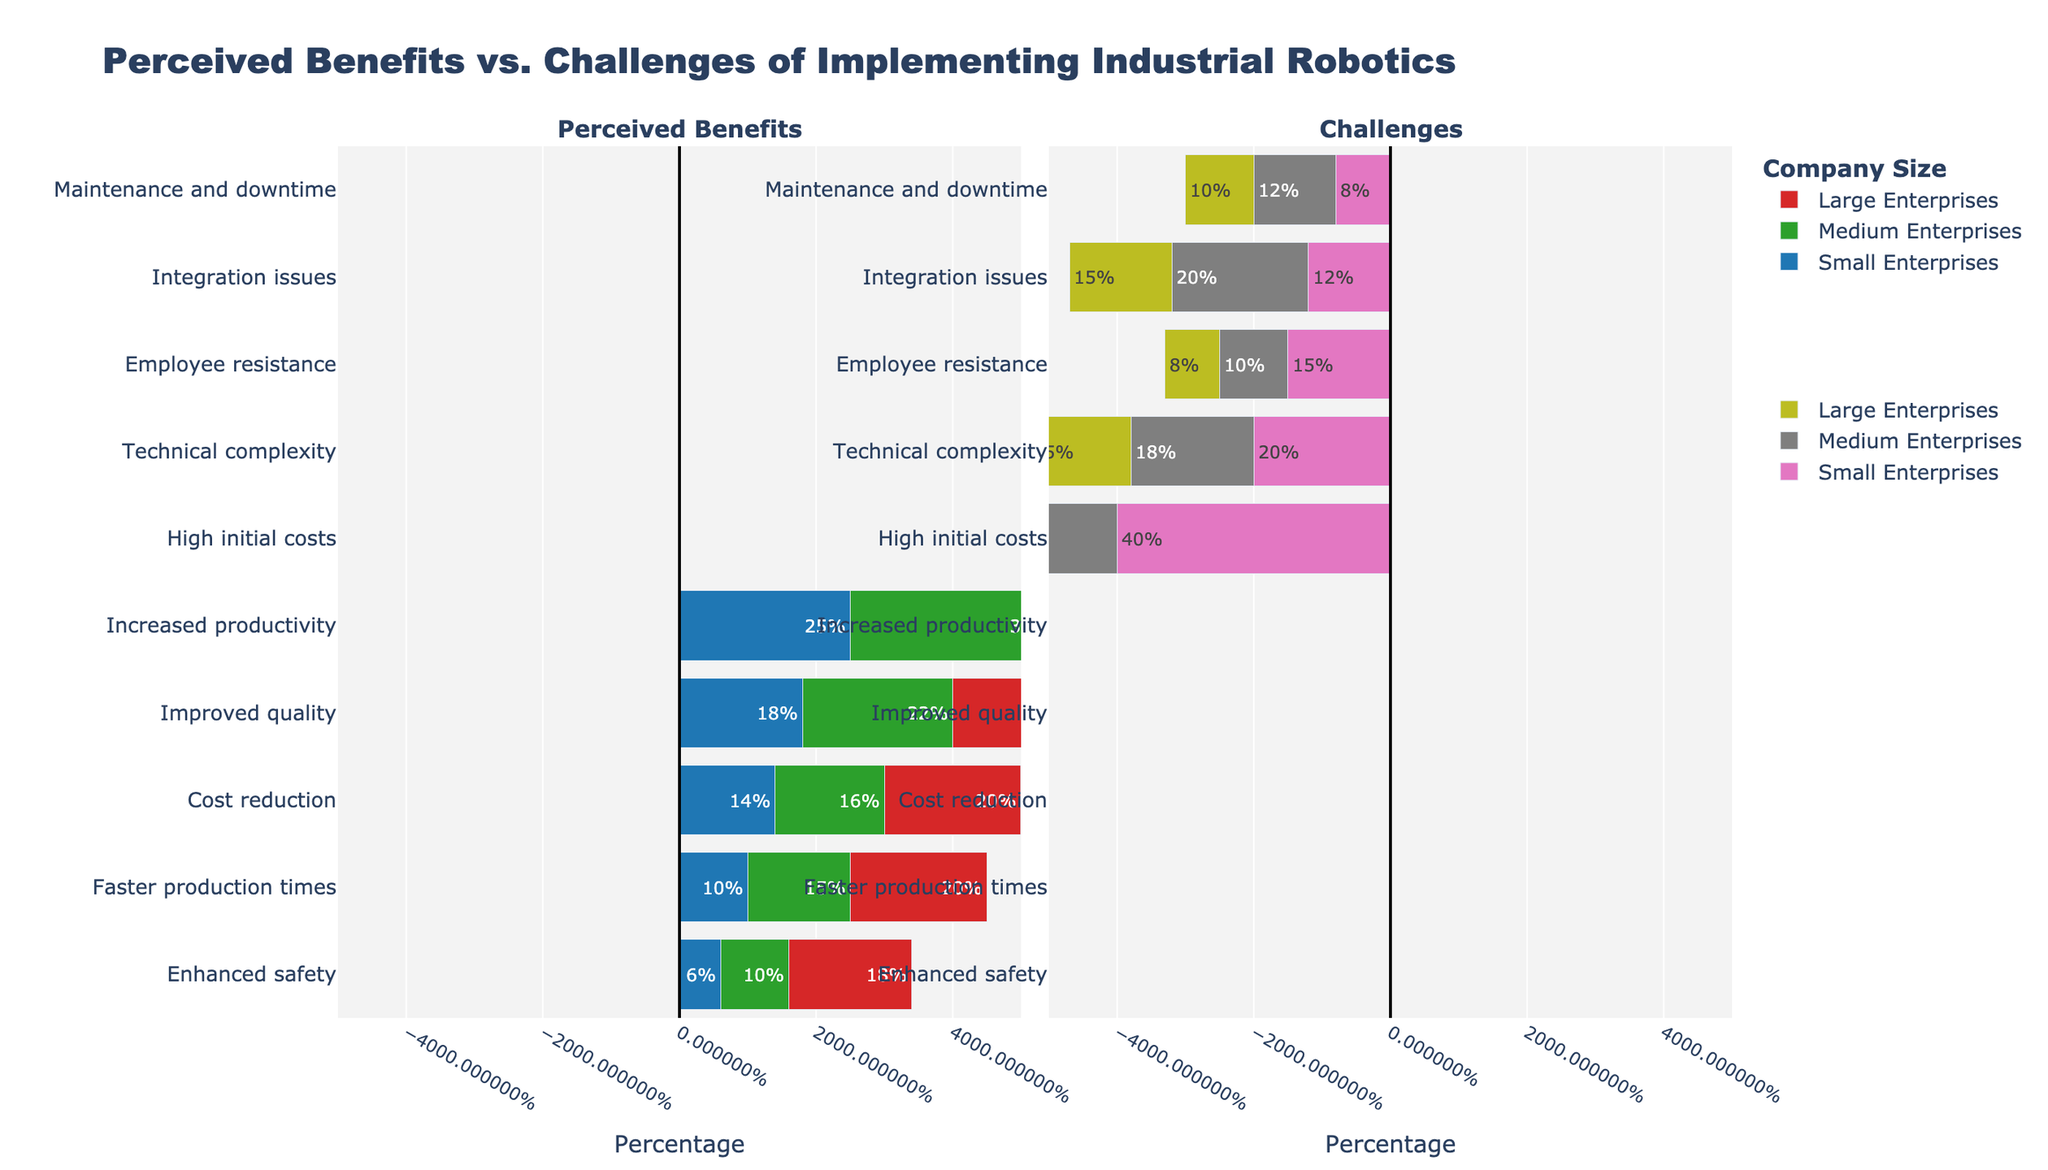Which company size perceives the highest increase in productivity due to industrial robotics? For perceived benefits, look at the highest bar representing 'Increased productivity' in the left sub-plot. The largest bar for this category is for Large Enterprises with a value of 35%.
Answer: Large Enterprises What is the difference in the percentage of companies perceiving high initial costs as a challenge between Small Enterprises and Large Enterprises? Compare the 'High initial costs' bars for Small Enterprises and Large Enterprises in the Challenges sub-plot. Small Enterprises show 40% while Large Enterprises show 20%. Subtract 20% from 40%.
Answer: 20% Among the company sizes, which one has the smallest percentage of employee resistance as a challenge? Look at the 'Employee resistance' bars in the Challenges sub-plot. The smallest percentage is for Large Enterprises, which is 8%.
Answer: Large Enterprises How does the perceived benefit of enhanced safety compare between Small and Large Enterprises? Compare the 'Enhanced safety' bars in the Perceived Benefits sub-plot for both Small and Large Enterprises. Small Enterprises have a 6% benefit and Large Enterprises have an 18% benefit.
Answer: Large Enterprises have a higher benefit What is the sum of the perceived benefits percentages for faster production times and cost reduction for Medium Enterprises? Add the percentages from the Perceived Benefits sub-plot: 15% for Faster production times and 16% for Cost reduction for Medium Enterprises.
Answer: 31% Which perceived benefit has the smallest percentage for Small Enterprises? Look for the smallest bar in the Perceived Benefits sub-plot for Small Enterprises. The smallest percentage is for 'Enhanced safety' at 6%.
Answer: Enhanced safety Is the percentage of perceived improved quality as a benefit higher or lower for Medium Enterprises compared to Small Enterprises? Compare the 'Improved quality' bars in the Perceived Benefits sub-plot for both Medium (22%) and Small Enterprises (18%).
Answer: Higher Which company size finds technical complexity as a challenge the least? Compare the 'Technical complexity' bars in the Challenges sub-plot for all company sizes. The smallest percentage is for Large Enterprises at 15%.
Answer: Large Enterprises What is the total percentage of challenges perceived by Large Enterprises? Add the percentages from the Challenges sub-plot for Large Enterprises: 20% + 15% + 8% + 15% + 10%.
Answer: 68% How do the integration issues compare between Medium and Large Enterprises? Compare the 'Integration issues' bars in the Challenges sub-plot for Medium Enterprises (20%) and Large Enterprises (15%).
Answer: Higher for Medium Enterprises 